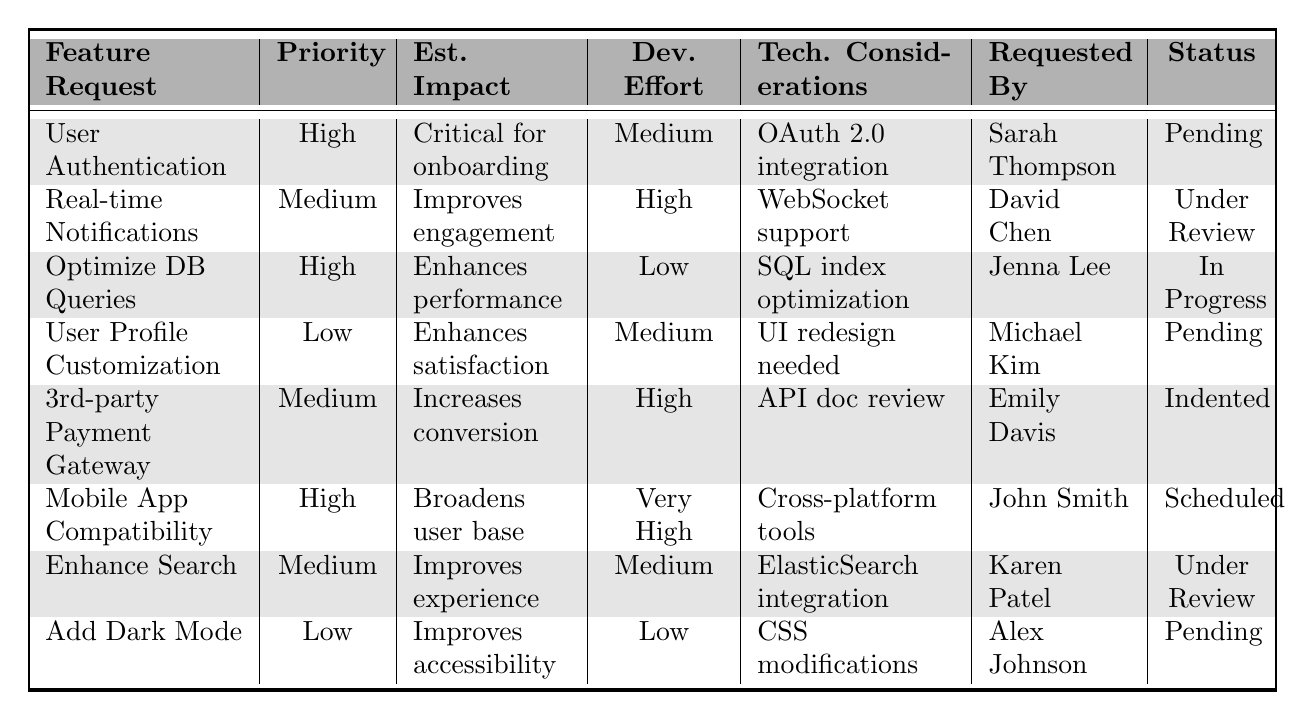What is the status of the "User Profile Customization" feature request? Referring to the table, the status of "User Profile Customization" is listed in the last column as "Pending."
Answer: Pending Who requested the "Integrate Third-party Payment Gateway" feature? Looking at the "Requested By" column, the feature "Integrate Third-party Payment Gateway" is requested by Emily Davis.
Answer: Emily Davis How many feature requests have a "High" priority? By examining the "Priority" column, there are three entries with "High" priority: "User Authentication System," "Optimize Database Queries," and "Mobile App Compatibility."
Answer: 3 Is there a feature request with a "Low" priority that is currently "In Progress"? The table shows no feature requests with "Low" priority and a status of "In Progress." Therefore, the answer is no.
Answer: No What is the estimated impact of the "Add Dark Mode" feature request? Looking at the "Est. Impact" column, the estimated impact for "Add Dark Mode" is "Improves accessibility."
Answer: Improves accessibility Which feature request has the highest development effort, and what is its status? The feature request "Mobile App Compatibility" has a "Very High" development effort listed, and its status is "Scheduled."
Answer: Mobile App Compatibility, Scheduled How many feature requests are currently "Pending"? The feature requests with a status of "Pending" are "Implement User Authentication System," "User Profile Customization," and "Add Dark Mode." Counting these gives a total of three.
Answer: 3 What is the difference in development effort between the "Optimize Database Queries" and "Mobile App Compatibility" requests? "Optimize Database Queries" has "Low" development effort, while "Mobile App Compatibility" has "Very High." The difference is between Low and Very High, indicating a significant increase in effort needed for the latter.
Answer: Significant increase Which technical consideration is required for the "Enhance Search Functionality"? In the "Technical Considerations" column, "Consider ElasticSearch integration" is listed as the requirement for "Enhance Search Functionality."
Answer: Consider ElasticSearch integration If we combine the estimated impacts of all the "High" priority feature requests, which aspect of the software would be most significantly enhanced? The "High" priority requests focus on aspects like user onboarding, performance enhancement, and broadening the user base, indicating a strong emphasis on improving user experience and accessibility.
Answer: User experience and accessibility 